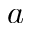Convert formula to latex. <formula><loc_0><loc_0><loc_500><loc_500>a</formula> 